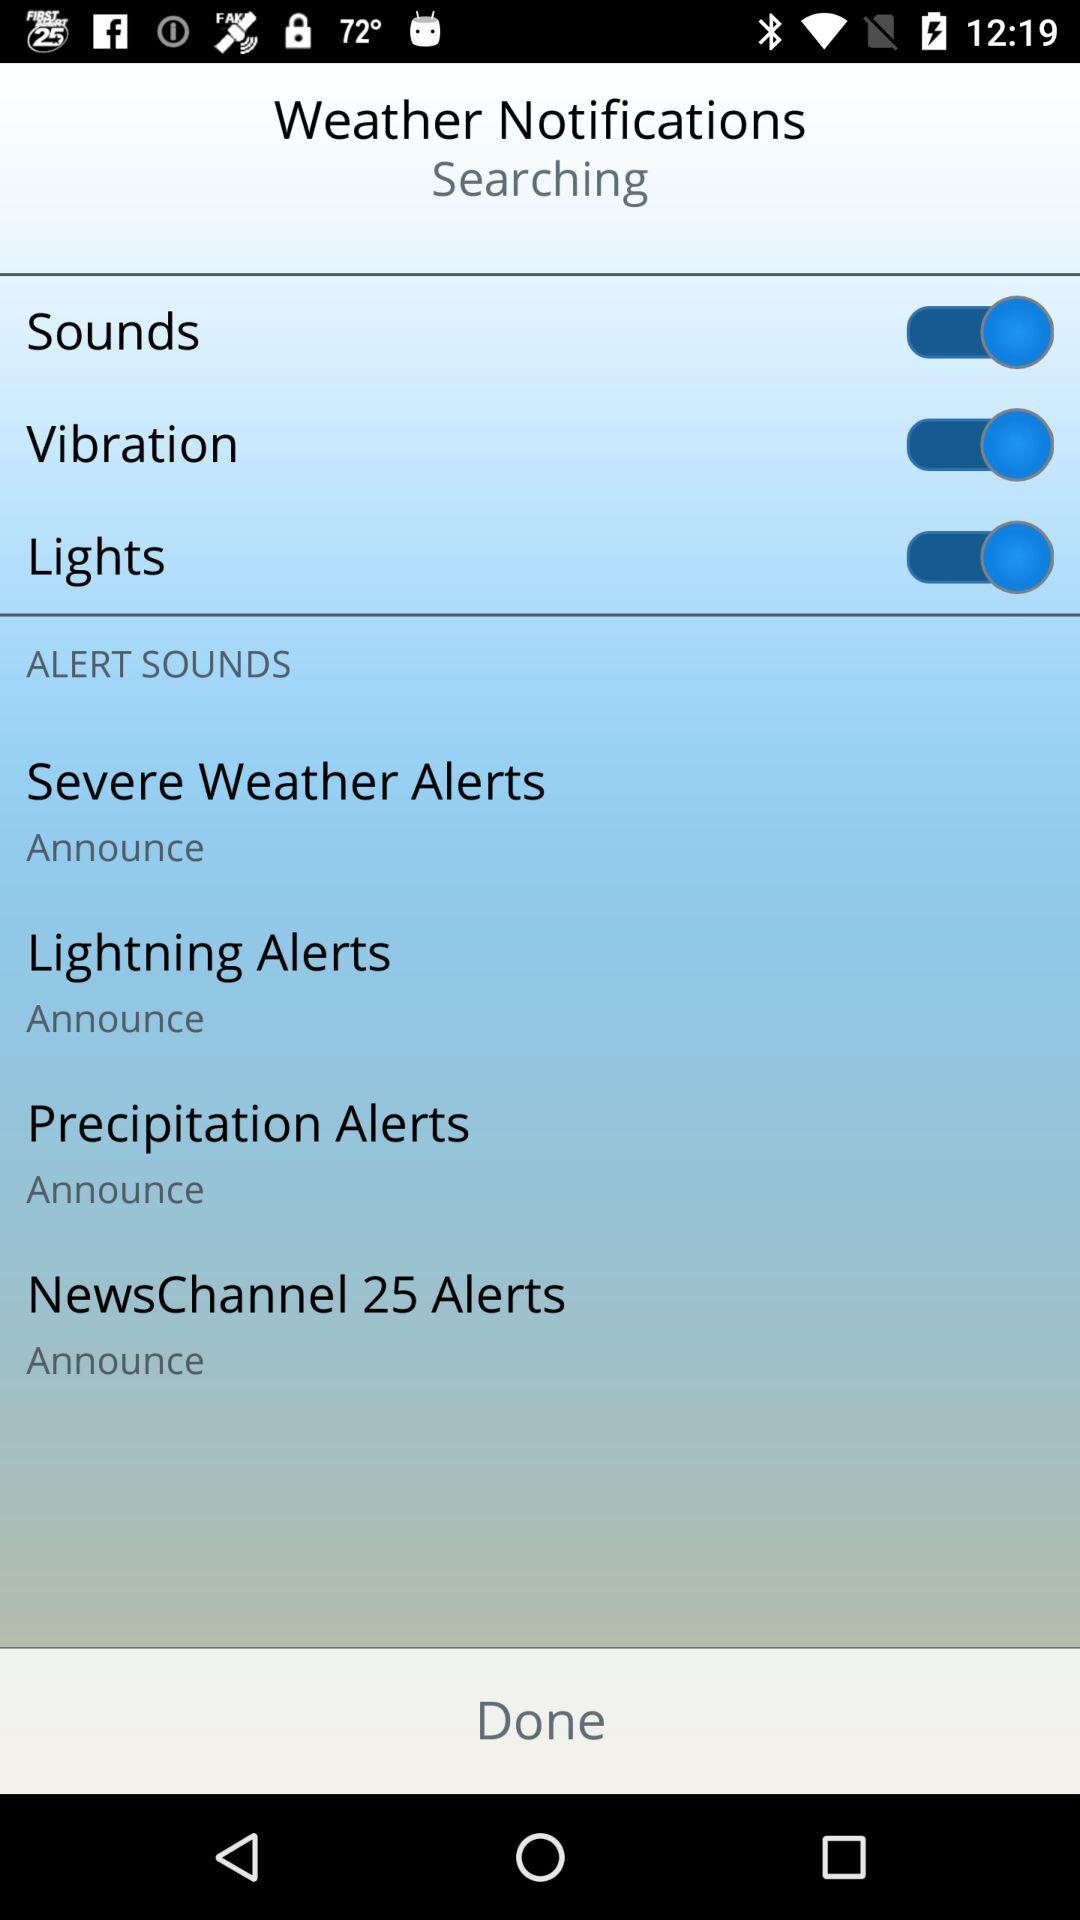What's the setting for lightning alerts? The setting is "Announce". 